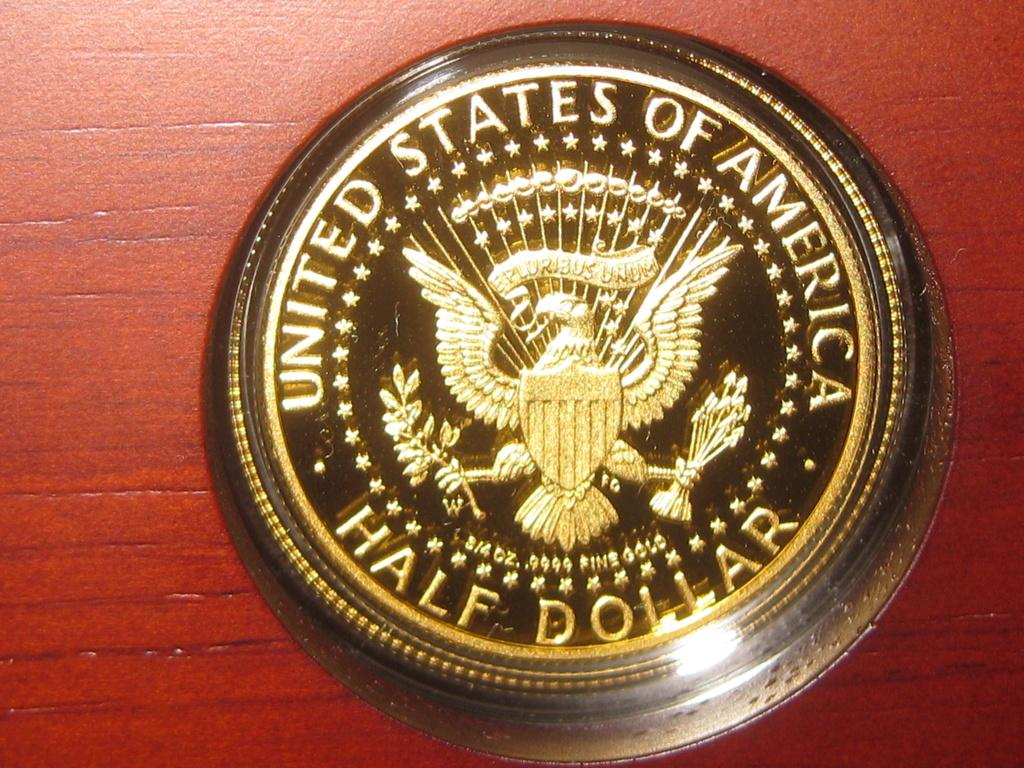<image>
Offer a succinct explanation of the picture presented. A United States half dollar that is black with gold text. 